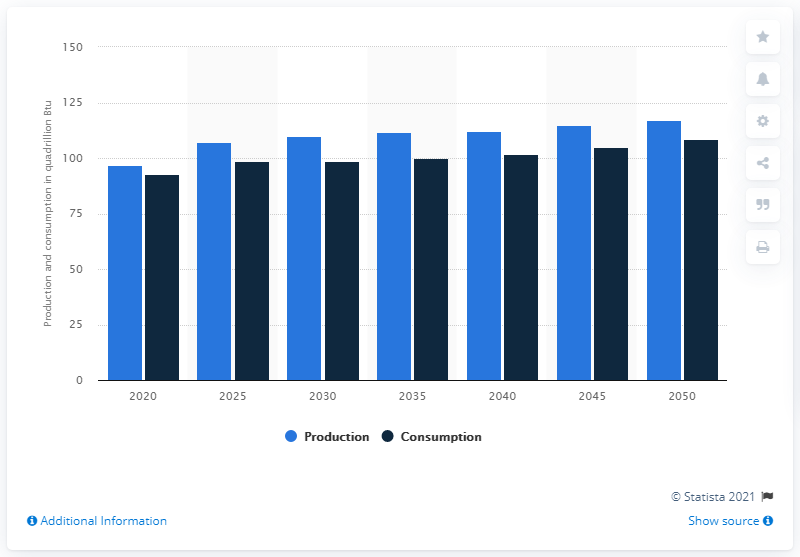Draw attention to some important aspects in this diagram. By the year 2050, it is projected that energy production in the United States will reach approximately 117 Btu. 